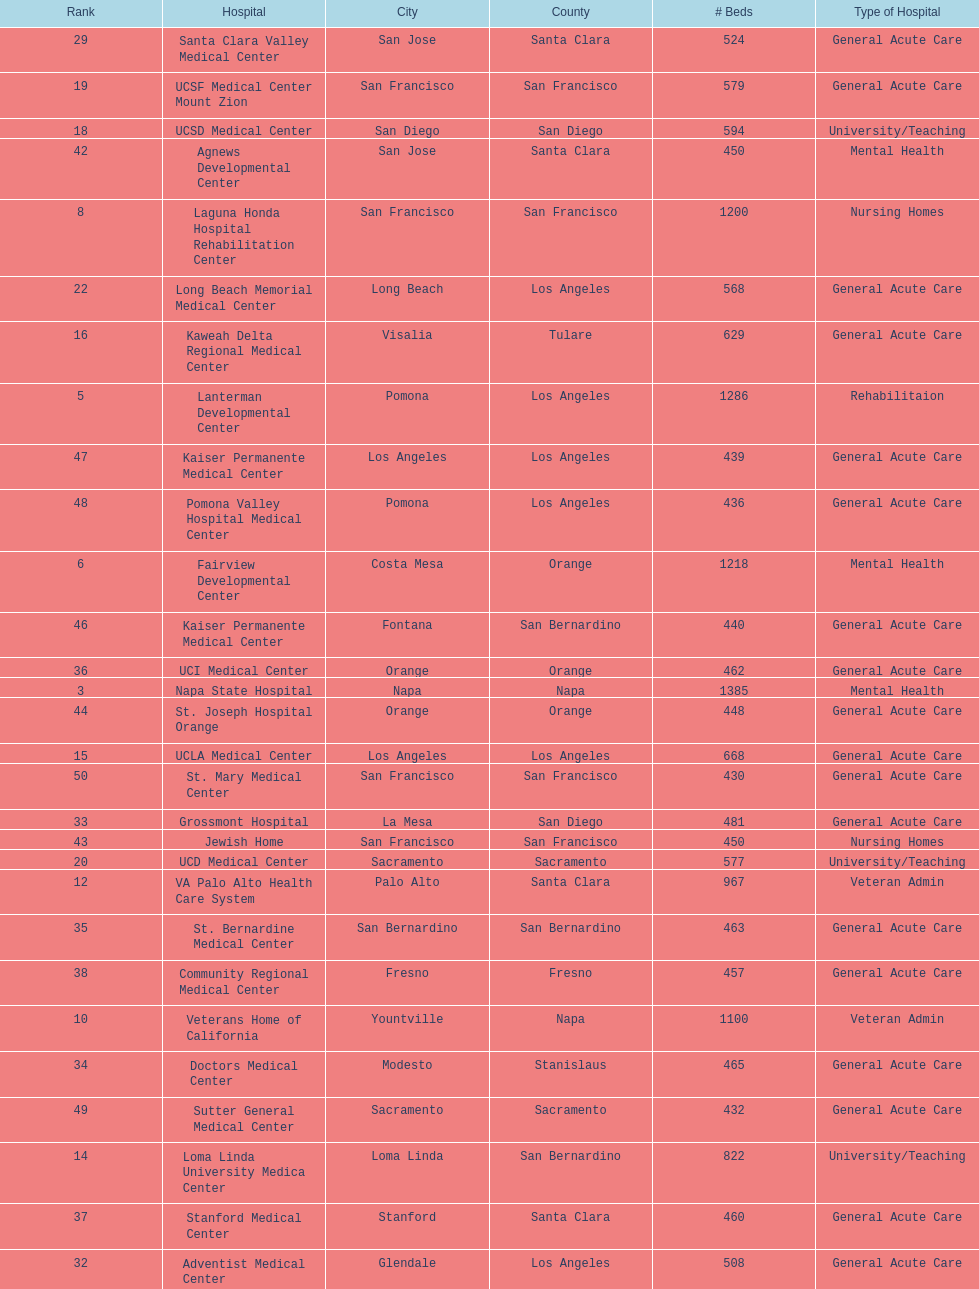How many hospital's have at least 600 beds? 17. I'm looking to parse the entire table for insights. Could you assist me with that? {'header': ['Rank', 'Hospital', 'City', 'County', '# Beds', 'Type of Hospital'], 'rows': [['29', 'Santa Clara Valley Medical Center', 'San Jose', 'Santa Clara', '524', 'General Acute Care'], ['19', 'UCSF Medical Center Mount Zion', 'San Francisco', 'San Francisco', '579', 'General Acute Care'], ['18', 'UCSD Medical Center', 'San Diego', 'San Diego', '594', 'University/Teaching'], ['42', 'Agnews Developmental Center', 'San Jose', 'Santa Clara', '450', 'Mental Health'], ['8', 'Laguna Honda Hospital Rehabilitation Center', 'San Francisco', 'San Francisco', '1200', 'Nursing Homes'], ['22', 'Long Beach Memorial Medical Center', 'Long Beach', 'Los Angeles', '568', 'General Acute Care'], ['16', 'Kaweah Delta Regional Medical Center', 'Visalia', 'Tulare', '629', 'General Acute Care'], ['5', 'Lanterman Developmental Center', 'Pomona', 'Los Angeles', '1286', 'Rehabilitaion'], ['47', 'Kaiser Permanente Medical Center', 'Los Angeles', 'Los Angeles', '439', 'General Acute Care'], ['48', 'Pomona Valley Hospital Medical Center', 'Pomona', 'Los Angeles', '436', 'General Acute Care'], ['6', 'Fairview Developmental Center', 'Costa Mesa', 'Orange', '1218', 'Mental Health'], ['46', 'Kaiser Permanente Medical Center', 'Fontana', 'San Bernardino', '440', 'General Acute Care'], ['36', 'UCI Medical Center', 'Orange', 'Orange', '462', 'General Acute Care'], ['3', 'Napa State Hospital', 'Napa', 'Napa', '1385', 'Mental Health'], ['44', 'St. Joseph Hospital Orange', 'Orange', 'Orange', '448', 'General Acute Care'], ['15', 'UCLA Medical Center', 'Los Angeles', 'Los Angeles', '668', 'General Acute Care'], ['50', 'St. Mary Medical Center', 'San Francisco', 'San Francisco', '430', 'General Acute Care'], ['33', 'Grossmont Hospital', 'La Mesa', 'San Diego', '481', 'General Acute Care'], ['43', 'Jewish Home', 'San Francisco', 'San Francisco', '450', 'Nursing Homes'], ['20', 'UCD Medical Center', 'Sacramento', 'Sacramento', '577', 'University/Teaching'], ['12', 'VA Palo Alto Health Care System', 'Palo Alto', 'Santa Clara', '967', 'Veteran Admin'], ['35', 'St. Bernardine Medical Center', 'San Bernardino', 'San Bernardino', '463', 'General Acute Care'], ['38', 'Community Regional Medical Center', 'Fresno', 'Fresno', '457', 'General Acute Care'], ['10', 'Veterans Home of California', 'Yountville', 'Napa', '1100', 'Veteran Admin'], ['34', 'Doctors Medical Center', 'Modesto', 'Stanislaus', '465', 'General Acute Care'], ['49', 'Sutter General Medical Center', 'Sacramento', 'Sacramento', '432', 'General Acute Care'], ['14', 'Loma Linda University Medica Center', 'Loma Linda', 'San Bernardino', '822', 'University/Teaching'], ['37', 'Stanford Medical Center', 'Stanford', 'Santa Clara', '460', 'General Acute Care'], ['32', 'Adventist Medical Center', 'Glendale', 'Los Angeles', '508', 'General Acute Care'], ['41', 'Hoag Memorial Hospital', 'Newport Beach', 'Orange', '450', 'General Acute Care'], ['50', 'Good Samaritan Hospital', 'San Jose', 'Santa Clara', '429', 'General Acute Care'], ['17', 'Naval Medical Center', 'San Diego', 'San Diego', '620', 'Military'], ['11', 'Metropolitan State Hospital', 'Norwalk', 'Los Angeles', '1096', 'Mental Health'], ['2', 'LA County & USC Medical Center', 'Los Angeles', 'Los Angeles', '1395', 'General Acute Care'], ['27', 'UCSF Medical Center at Parnassus', 'San Francisco', 'San Francisco', '536', 'General Acute Care'], ['23', 'Harbor UCLA Medical Center', 'Torrance', 'Los Angeles', '553', 'General Acute Care'], ['30', 'Scripps Mercy Hospital', 'San Diego', 'San Diego', '523', 'General Acute Care'], ['7', 'Porterville Developmental Center', 'Porterville', 'Tulare', '1210', 'Mental Health'], ['26', 'San Francisco General Hospital', 'San Francisco', 'San Francisco', '550', 'General Acute Care'], ['39', 'Methodist Hospital', 'Arcadia', 'Los Angeles', '455', 'General Acute Care'], ['24', 'Mission Hospital Regional Medical Center', 'Mission Viejo', 'Orange', '552', 'General Acute Care'], ['28', 'Alta Bates Summit Medical Center', 'Oakland', 'Alameda', '534', 'General Acute Care'], ['31', 'Huntington Memorial Hospital', 'Pasadena', 'Los Angeles', '522', 'General Acute Care'], ['25', 'Alta Bates Summit Medical Center', 'Berkeley', 'Alameda', '551', 'General Acute Care'], ['40', 'Providence St. Joseph Medical Center', 'Burbank', 'Los Angeles', '455', 'General Acute Care'], ['21', 'California Pacific/Calif Campus', 'San Francisco', 'San Francisco', '572', 'General Acute Care'], ['13', 'Cedars-Sinai Medical Center', 'West Hollywood', 'Los Angeles', '952', 'General Acute Care'], ['1', 'Patton State Hospital', 'Patton', 'San Bernardino', '1500', 'Mental Health'], ['4', 'Sonoma Developmental Center', 'Eldridge', 'Sonoma', '1300', 'Mental Health'], ['45', 'Presbyterian Intercommunity', 'Whittier', 'Los Angeles', '441', 'General Acute Care'], ['9', 'Atascadero State Hospital', 'Atascadero', 'San Luis Obispo', '1200', 'Mental Health']]} 